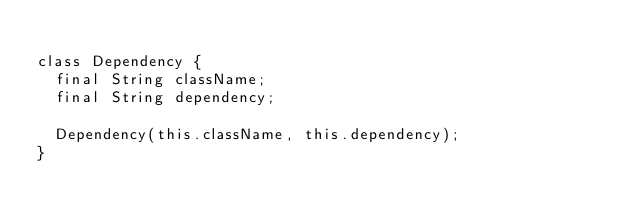<code> <loc_0><loc_0><loc_500><loc_500><_Dart_>
class Dependency {
  final String className;
  final String dependency;

  Dependency(this.className, this.dependency);
}</code> 